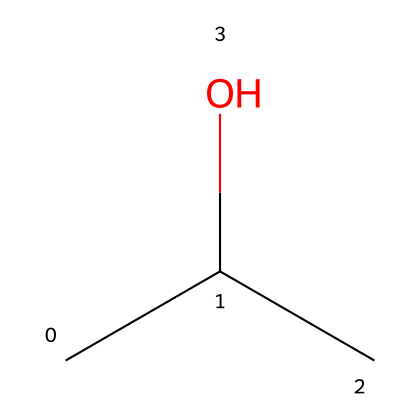What is the common name for this chemical? The SMILES representation CC(C)O corresponds to isopropyl alcohol, which is its common name.
Answer: isopropyl alcohol How many carbon atoms are in isopropyl alcohol? Analyzing the structure from the SMILES CC(C)O shows there are three carbon (C) atoms present (two from the "CC" and one from the branching connected to the central carbon).
Answer: 3 What is the functional group present in isopropyl alcohol? The hydroxyl group (-OH) indicated by the "O" in the SMILES CC(C)O identifies the functional group, which is characteristic of alcohols.
Answer: hydroxyl Is isopropyl alcohol a flammable liquid? Isopropyl alcohol has a flash point of approximately 12 °C, demonstrating its flammable nature as a liquid.
Answer: yes What type of bond connects the carbon and oxygen in isopropyl alcohol? The bond between carbon and oxygen in isopropyl alcohol is a covalent bond, specifically a single bond. This is due to the direct connection indicated by the structure CC(C)O.
Answer: covalent How many hydrogen atoms are present in isopropyl alcohol? The total number of hydrogen atoms can be deduced by examining the structure: each carbon (C) essentially can bond with up to four atoms. There are 8 hydrogen atoms in isopropyl alcohol considering the configuration of the structure.
Answer: 8 What physical state is isopropyl alcohol typically found in? Isopropyl alcohol is typically found in liquid form at room temperature, indicated by its properties as a flammable liquid.
Answer: liquid 